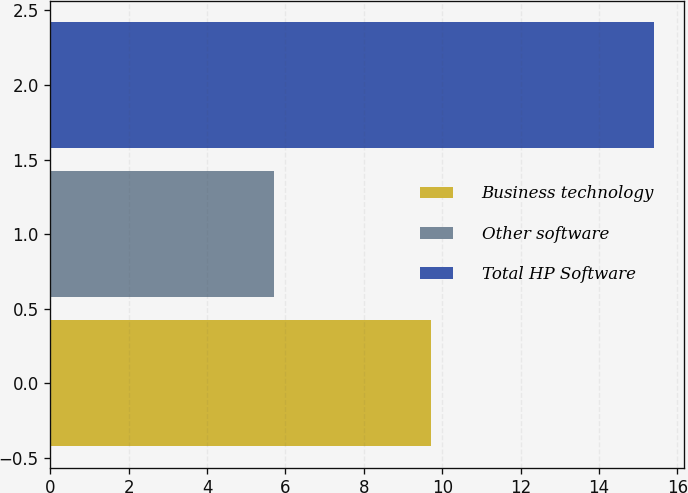Convert chart. <chart><loc_0><loc_0><loc_500><loc_500><bar_chart><fcel>Business technology<fcel>Other software<fcel>Total HP Software<nl><fcel>9.7<fcel>5.7<fcel>15.4<nl></chart> 